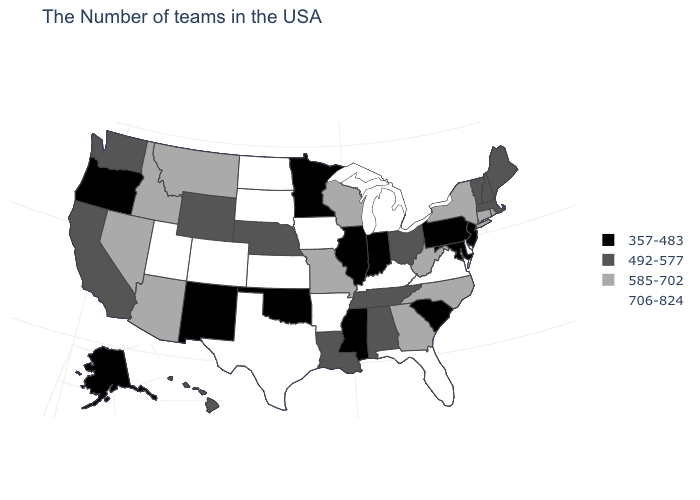Which states hav the highest value in the West?
Answer briefly. Colorado, Utah. How many symbols are there in the legend?
Short answer required. 4. Does the first symbol in the legend represent the smallest category?
Write a very short answer. Yes. What is the value of Nevada?
Concise answer only. 585-702. Among the states that border Montana , does North Dakota have the lowest value?
Write a very short answer. No. Name the states that have a value in the range 357-483?
Concise answer only. New Jersey, Maryland, Pennsylvania, South Carolina, Indiana, Illinois, Mississippi, Minnesota, Oklahoma, New Mexico, Oregon, Alaska. Name the states that have a value in the range 585-702?
Answer briefly. Rhode Island, Connecticut, New York, North Carolina, West Virginia, Georgia, Wisconsin, Missouri, Montana, Arizona, Idaho, Nevada. Is the legend a continuous bar?
Write a very short answer. No. Does Kentucky have the lowest value in the USA?
Short answer required. No. Does New Jersey have a lower value than Pennsylvania?
Quick response, please. No. What is the value of West Virginia?
Write a very short answer. 585-702. Name the states that have a value in the range 492-577?
Keep it brief. Maine, Massachusetts, New Hampshire, Vermont, Ohio, Alabama, Tennessee, Louisiana, Nebraska, Wyoming, California, Washington, Hawaii. Name the states that have a value in the range 492-577?
Concise answer only. Maine, Massachusetts, New Hampshire, Vermont, Ohio, Alabama, Tennessee, Louisiana, Nebraska, Wyoming, California, Washington, Hawaii. What is the highest value in states that border New York?
Be succinct. 585-702. Is the legend a continuous bar?
Short answer required. No. 